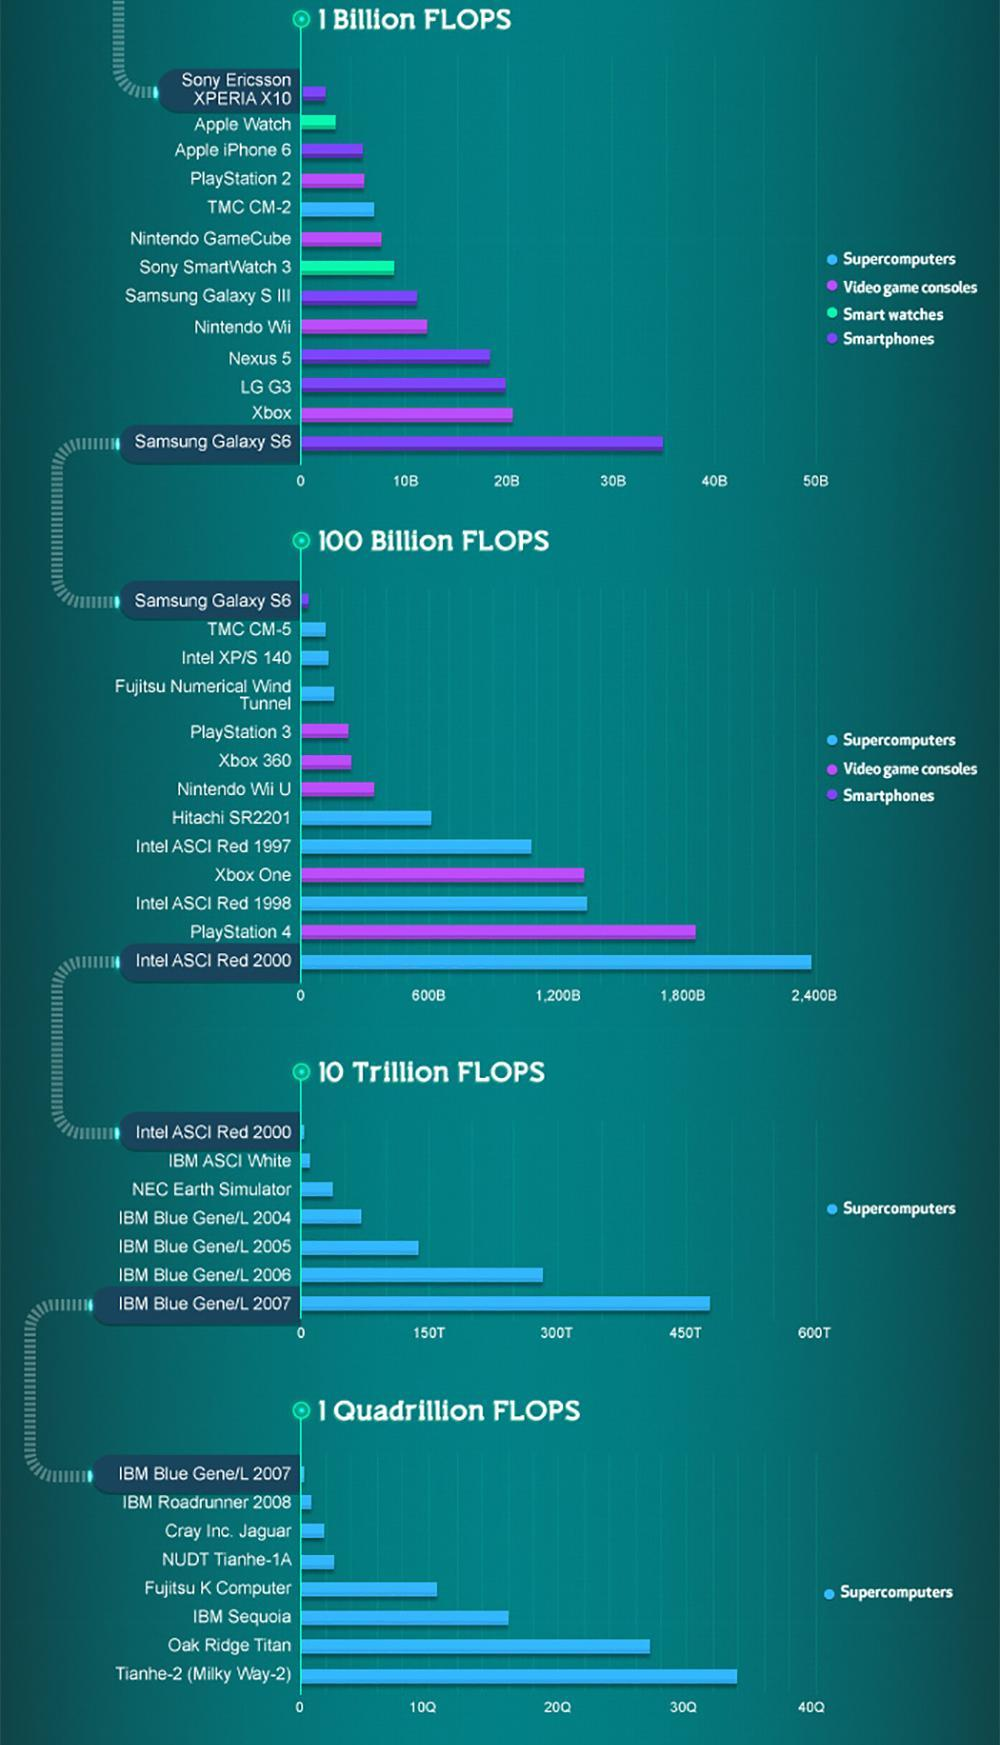What is the measure of computer performance?
Answer the question with a short phrase. FLOPS Which color is used to represent smart watches-violet, green, blue? green 